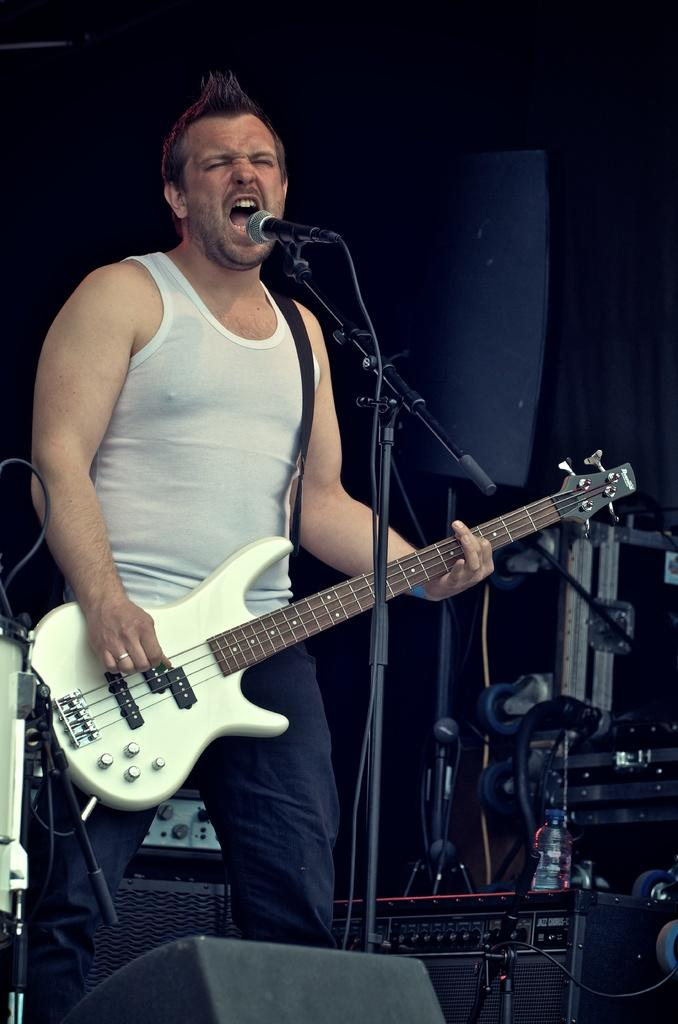What is the man in the image doing? The man is playing a guitar in the image. What equipment is present for amplifying sound? There are microphone stands, a microphone, and speakers in the image. Can you describe the objects in the background of the image? Unfortunately, the provided facts do not give specific details about the objects in the background. What type of collar can be seen on the man's pet in the image? There is no pet or collar present in the image. Can you describe the ornament on the vase in the image? There is no vase or ornament present in the image. 